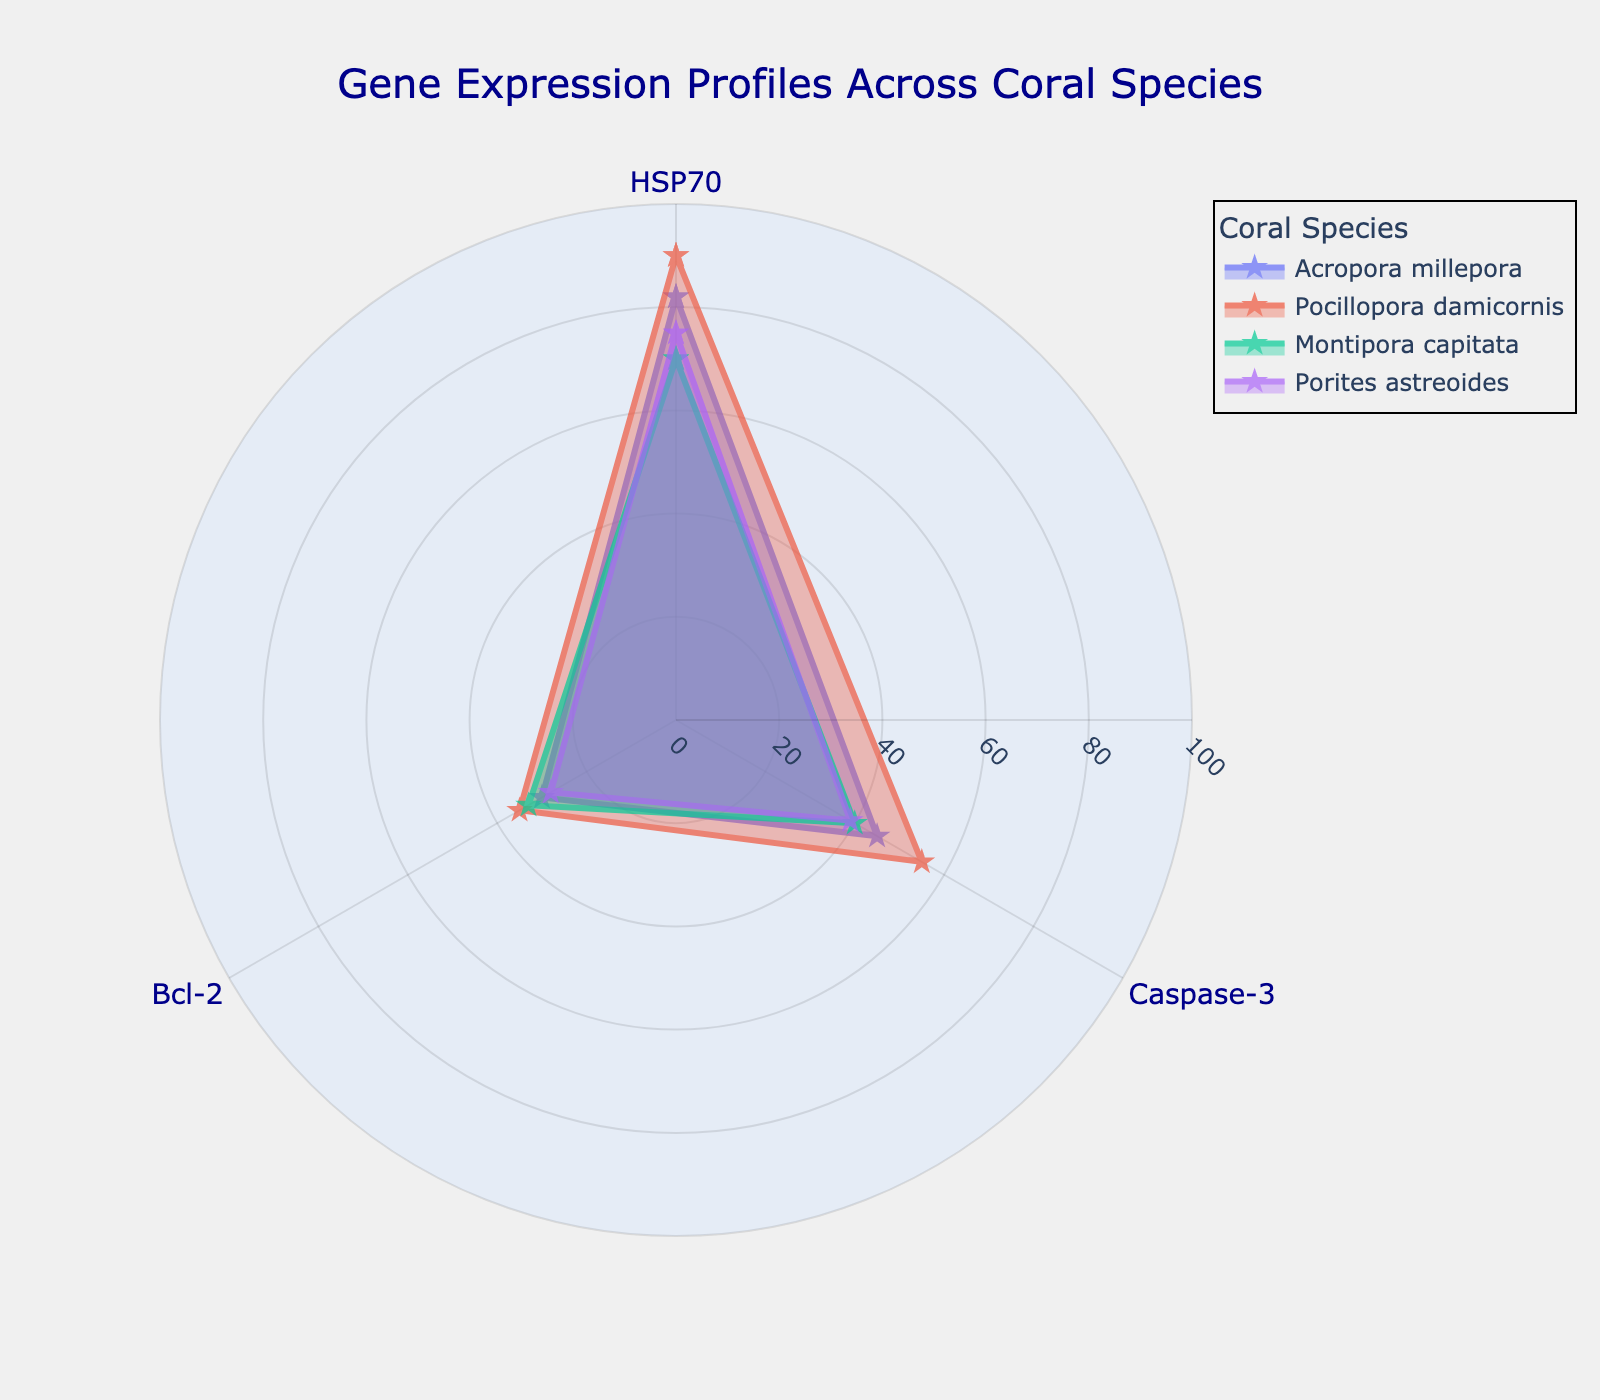What is the title of the figure? The title is located at the top of the figure and provides a summary of the content presented.
Answer: Gene Expression Profiles Across Coral Species How many coral species are represented in the figure? Look at the legend to count the distinct coral species listed.
Answer: Four Which coral species has the highest expression level of HSP70? Compare the values of HSP70 for each species and identify the highest one.
Answer: Pocillopora damicornis What is the difference in expression levels of Bcl-2 between Acropora millepora and Porites astreoides? Find the Bcl-2 expression levels of both species and calculate the difference: 30 (Acropora millepora) and 28 (Porites astreoides).
Answer: 2 How is the angular axis labeled? Inspect the labels around the polar chart to identify how the axis is marked.
Answer: With gene names (HSP70, Caspase-3, Bcl-2) Which species shows the most even expression levels across all three genes? Compare the radial lengths to observe which species has relatively similar values for all genes.
Answer: Montipora capitata What is the average expression level of Caspase-3 across all species? Sum the Caspase-3 values for all species and divide by the number of species: (45 + 55 + 40 + 39) / 4.
Answer: 44.75 Which coral species has the widest range in gene expression levels? Find the range of expression levels (maximum minus minimum) for each species and determine the widest.
Answer: Acropora millepora Which gene expression level has the closest values for all species? Compare the expression levels of each gene across all species and identify the gene with the least variation.
Answer: Bcl-2 Is any species' expression level of HSP70 lower than their Caspase-3 expression level? Compare HSP70 and Caspase-3 values for each species to see if any HSP70 is less than Caspase-3.
Answer: No 